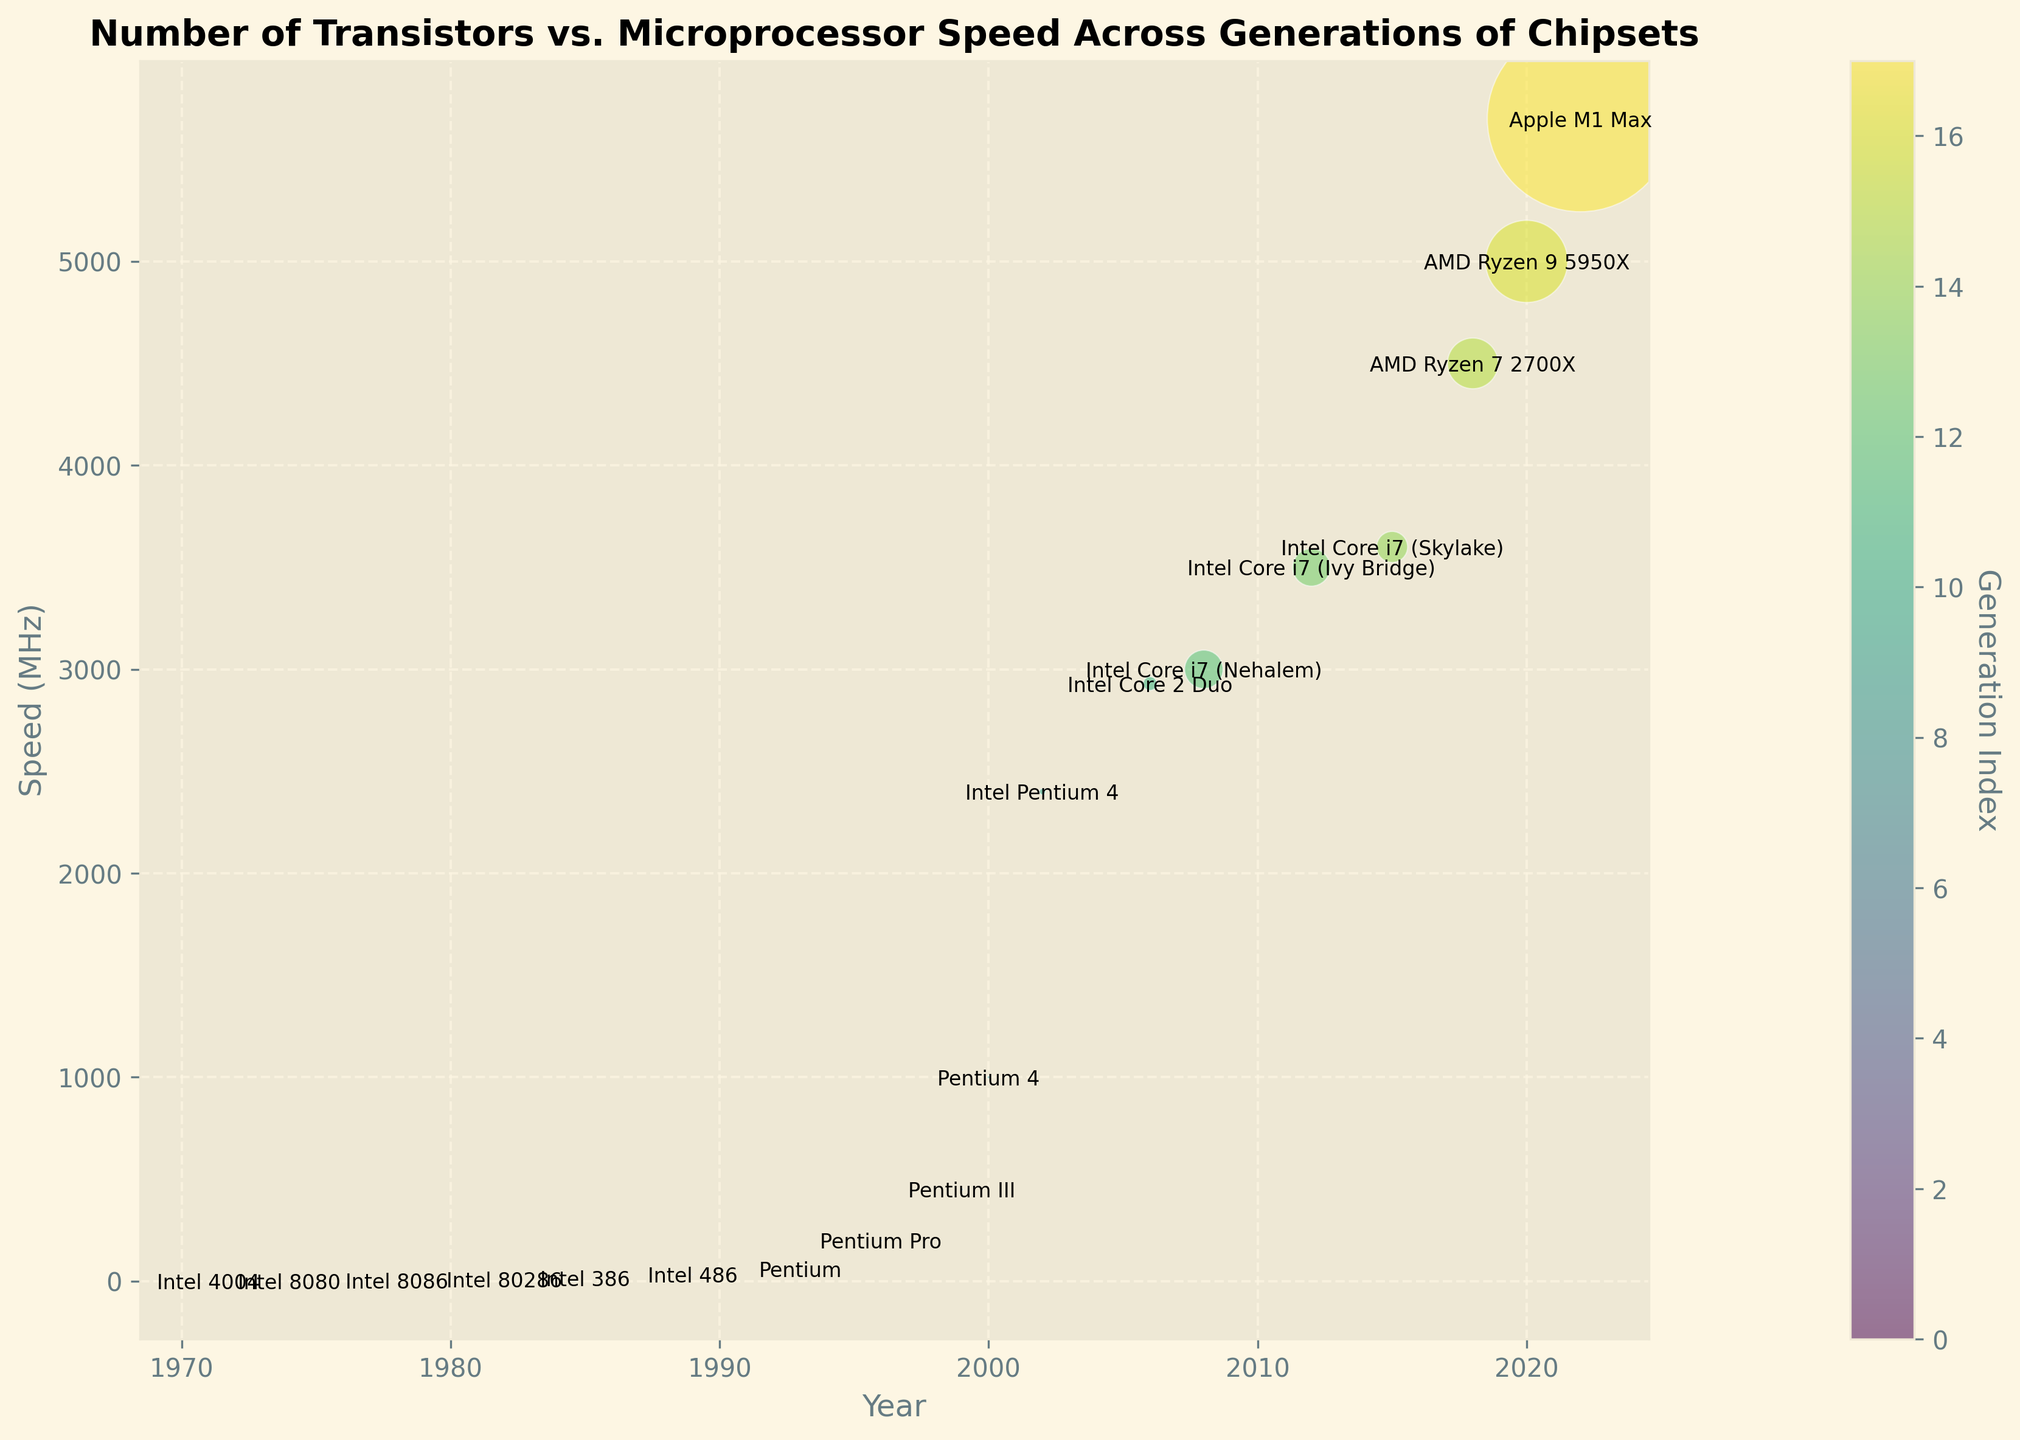Which chipset has the highest speed? Since the highest point on the vertical axis (Speed) is at 5700 MHz, and the bubble associated with this value belongs to the "Apple M1 Max" chipset according to the label.
Answer: Apple M1 Max What is the trend in the number of transistors over time? From 1971 to 2022, there is a noticeable upward trend in the number of transistors, indicating that the number of transistors in chipsets has significantly increased over time. This is evidenced by the larger bubble sizes as you move from left (earlier years) to right (later years).
Answer: Upward trend Which chipset has a bubble with the largest area and what does it represent? The Apple M1 Max has the largest bubble area, which represents the highest number of transistors (54000 million) among the chipsets in the figure.
Answer: Apple M1 Max How does the speed of the Intel Core i7 (Skylake) compare to the Intel Core 2 Duo? The Intel Core i7 (Skylake) has a speed of 3600 MHz, while the Intel Core 2 Duo has a speed of 2930 MHz. Thus, the Intel Core i7 (Skylake) is faster.
Answer: Intel Core i7 (Skylake) is faster What is the speed difference between the Pentium 4 (2000) and Intel Pentium 4 (2002)? The Pentium 4 (2000) has a speed of 1000 MHz, while the Intel Pentium 4 (2002) has a speed of 2400 MHz. The difference is 2400 - 1000 = 1400 MHz.
Answer: 1400 MHz Which chipset in the plot has the lowest number of transistors and what is its speed? The Intel 4004 has the lowest number of transistors (0.0023 million) and its speed is 0.740 MHz, as indicated by the smallest bubble and the label next to it.
Answer: Intel 4004, 0.740 MHz Is there a correlation between the year and the number of transistors? Yes, the number of transistors increases as the year progresses, suggesting a positive correlation between the year and the number of transistors. This is demonstrated by larger bubbles in more recent years.
Answer: Positive correlation Which year had a chipset with a speed of 4500 MHz, and what is the name of the chipset? The year 2018 had a chipset with a speed of 4500 MHz, which is the AMD Ryzen 7 2700X as indicated by the label.
Answer: 2018, AMD Ryzen 7 2700X Compare the number of transistors between the AMD Ryzen 9 5950X and Intel Core i7 (Nehalem). The AMD Ryzen 9 5950X has 10500 million transistors, while the Intel Core i7 (Nehalem) has 2300 million transistors. Therefore, the AMD Ryzen 9 5950X has more transistors.
Answer: AMD Ryzen 9 5950X has more How does the generational development reflect in the number and speed of transistors for 2006 and 2012? The Intel Core 2 Duo (2006) has 291 million transistors and a speed of 2930 MHz. The Intel Core i7 (Ivy Bridge, 2012) has 2200 million transistors and a speed of 3500 MHz. This reflects an increase in both the number of transistors and speed over these generations.
Answer: Increase in both 